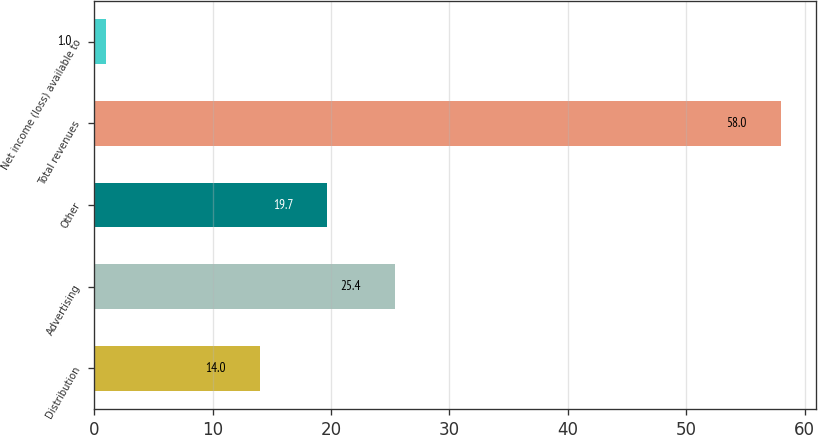Convert chart. <chart><loc_0><loc_0><loc_500><loc_500><bar_chart><fcel>Distribution<fcel>Advertising<fcel>Other<fcel>Total revenues<fcel>Net income (loss) available to<nl><fcel>14<fcel>25.4<fcel>19.7<fcel>58<fcel>1<nl></chart> 